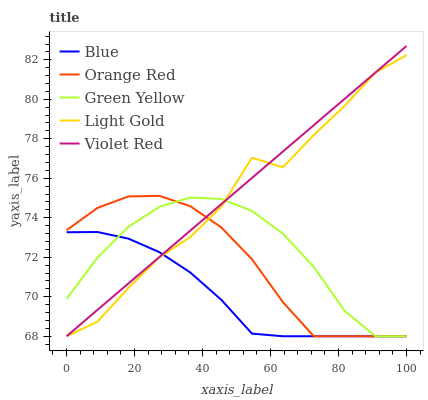Does Green Yellow have the minimum area under the curve?
Answer yes or no. No. Does Green Yellow have the maximum area under the curve?
Answer yes or no. No. Is Green Yellow the smoothest?
Answer yes or no. No. Is Green Yellow the roughest?
Answer yes or no. No. Does Green Yellow have the highest value?
Answer yes or no. No. 